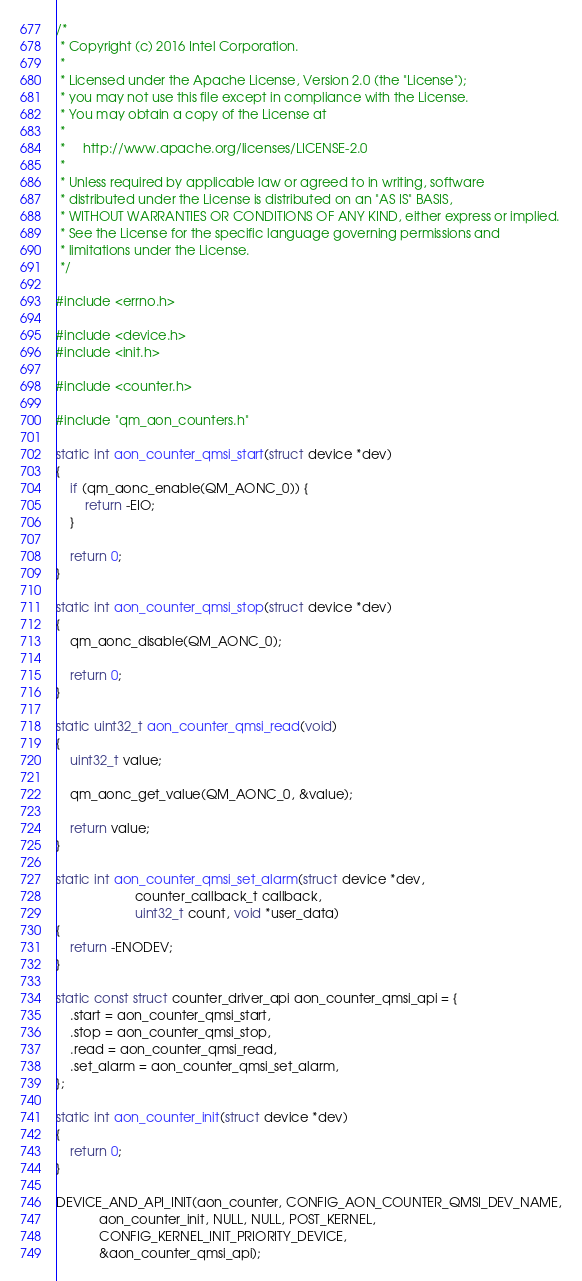<code> <loc_0><loc_0><loc_500><loc_500><_C_>/*
 * Copyright (c) 2016 Intel Corporation.
 *
 * Licensed under the Apache License, Version 2.0 (the "License");
 * you may not use this file except in compliance with the License.
 * You may obtain a copy of the License at
 *
 *     http://www.apache.org/licenses/LICENSE-2.0
 *
 * Unless required by applicable law or agreed to in writing, software
 * distributed under the License is distributed on an "AS IS" BASIS,
 * WITHOUT WARRANTIES OR CONDITIONS OF ANY KIND, either express or implied.
 * See the License for the specific language governing permissions and
 * limitations under the License.
 */

#include <errno.h>

#include <device.h>
#include <init.h>

#include <counter.h>

#include "qm_aon_counters.h"

static int aon_counter_qmsi_start(struct device *dev)
{
	if (qm_aonc_enable(QM_AONC_0)) {
		return -EIO;
	}

	return 0;
}

static int aon_counter_qmsi_stop(struct device *dev)
{
	qm_aonc_disable(QM_AONC_0);

	return 0;
}

static uint32_t aon_counter_qmsi_read(void)
{
	uint32_t value;

	qm_aonc_get_value(QM_AONC_0, &value);

	return value;
}

static int aon_counter_qmsi_set_alarm(struct device *dev,
				      counter_callback_t callback,
				      uint32_t count, void *user_data)
{
	return -ENODEV;
}

static const struct counter_driver_api aon_counter_qmsi_api = {
	.start = aon_counter_qmsi_start,
	.stop = aon_counter_qmsi_stop,
	.read = aon_counter_qmsi_read,
	.set_alarm = aon_counter_qmsi_set_alarm,
};

static int aon_counter_init(struct device *dev)
{
	return 0;
}

DEVICE_AND_API_INIT(aon_counter, CONFIG_AON_COUNTER_QMSI_DEV_NAME,
		    aon_counter_init, NULL, NULL, POST_KERNEL,
		    CONFIG_KERNEL_INIT_PRIORITY_DEVICE,
		    &aon_counter_qmsi_api);
</code> 